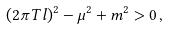Convert formula to latex. <formula><loc_0><loc_0><loc_500><loc_500>( 2 \pi T l ) ^ { 2 } - \mu ^ { 2 } + m ^ { 2 } > 0 \, ,</formula> 